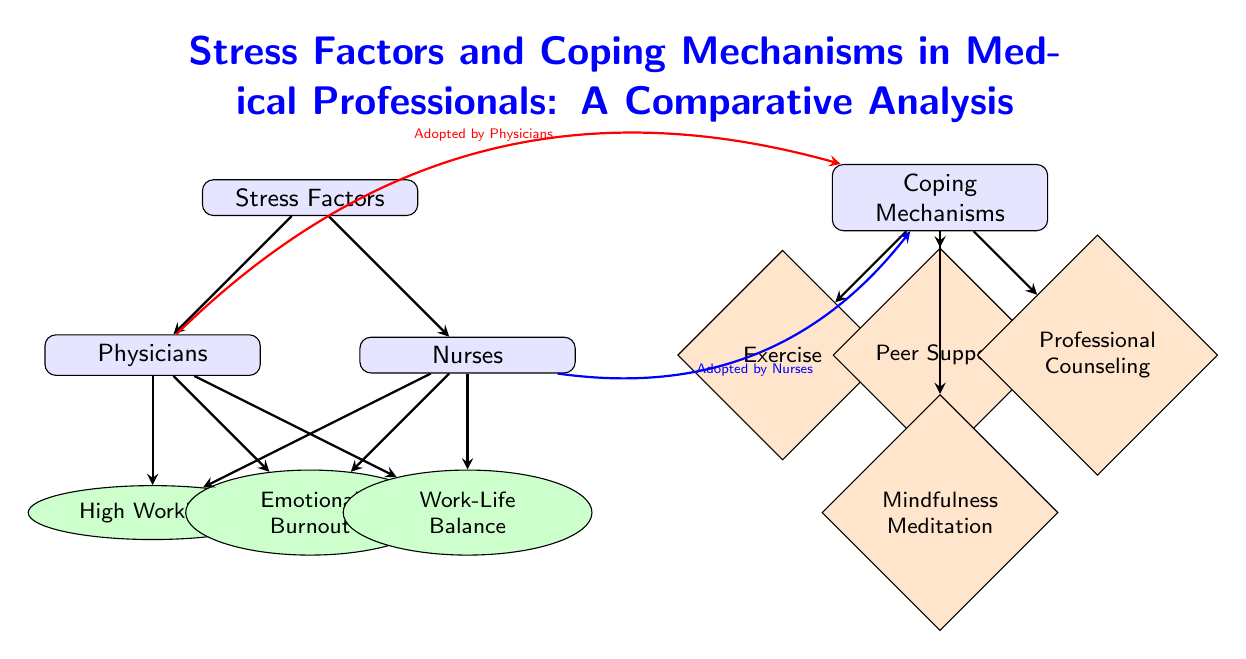What are the three main stress factors identified for medical professionals? The diagram lists three stress factors which are indicated as nodes connected to both physicians and nurses. They are "High Workload," "Emotional Burnout," and "Work-Life Balance."
Answer: High Workload, Emotional Burnout, Work-Life Balance Which coping mechanism is associated with mindfulness? The diagram shows "Mindfulness Meditation" as a coping mechanism node. It is connected to the main "Coping Mechanisms" section without direct arrows to physicians or nurses, indicating it is part of the overall coping strategies.
Answer: Mindfulness Meditation How many coping mechanisms are represented in the diagram? The coping mechanisms section lists four distinct mechanisms: "Exercise," "Peer Support," "Professional Counseling," and "Mindfulness Meditation," making the count straightforward.
Answer: 4 Which stress factor is most prominently connected to both physicians and nurses? The connections show that all three stress factors are linked to both physician and nurse nodes, but "High Workload" is listed first in the diagram, suggesting emphasis.
Answer: High Workload What mechanism is adopted by nurses according to the diagram? The arrows indicate which coping mechanisms are adopted by nurses. The mechanisms "Exercise," "Peer Support," "Professional Counseling," and "Mindfulness Meditation" are listed under the "Coping Mechanisms," confirming they are all options but do not specify exclusivity to nurses.
Answer: Exercise, Peer Support, Professional Counseling, Mindfulness Meditation Which group shows a connection to professional counseling? The diagram has a red thick arrow indicating a connection to the coping mechanism "Professional Counseling." By observing the arrows, we see this mechanism is positioned to be adopted by both physicians and nurses, represented by two distinct flows.
Answer: Physicians and Nurses 